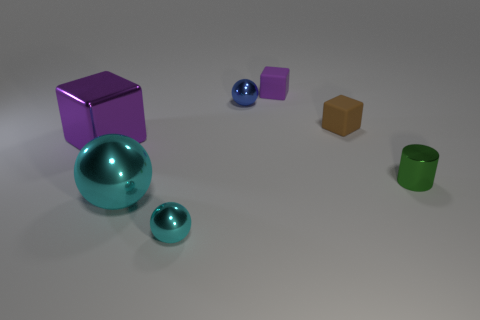What is the size of the purple metallic block?
Offer a terse response. Large. There is a brown block that is the same size as the purple matte block; what is its material?
Give a very brief answer. Rubber. What number of things are cubes that are behind the purple metal block or green metallic cylinders?
Your answer should be compact. 3. Is the number of small blue objects that are in front of the blue shiny object the same as the number of big metallic spheres?
Keep it short and to the point. No. What is the color of the tiny object that is in front of the purple metal block and on the right side of the blue metallic sphere?
Ensure brevity in your answer.  Green. What number of balls are either tiny shiny things or blue objects?
Offer a terse response. 2. Is the number of tiny cylinders that are on the left side of the brown matte cube less than the number of shiny spheres?
Your answer should be very brief. Yes. There is a tiny cyan thing that is the same material as the tiny blue ball; what is its shape?
Give a very brief answer. Sphere. What number of cylinders have the same color as the big block?
Offer a terse response. 0. How many objects are tiny purple rubber objects or green matte objects?
Your response must be concise. 1. 